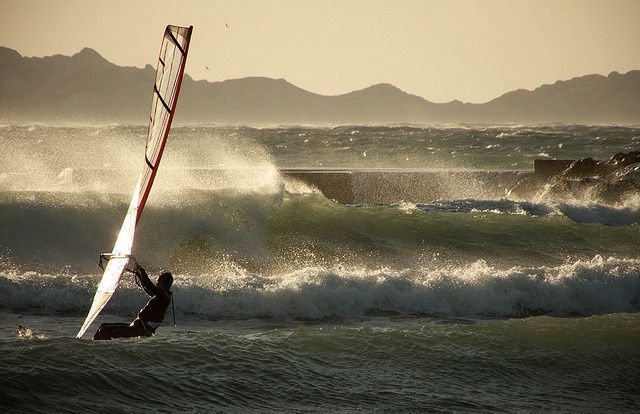Describe the objects in this image and their specific colors. I can see boat in tan, ivory, and maroon tones and people in tan, black, gray, maroon, and darkgreen tones in this image. 